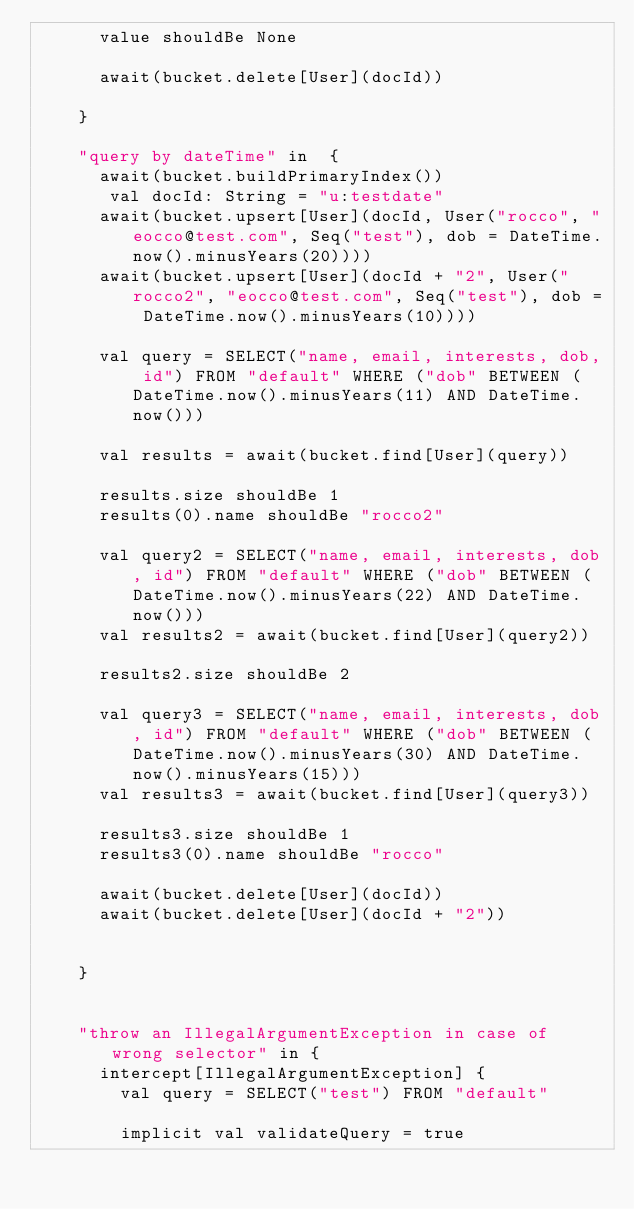Convert code to text. <code><loc_0><loc_0><loc_500><loc_500><_Scala_>      value shouldBe None

      await(bucket.delete[User](docId))

    }

    "query by dateTime" in  {
      await(bucket.buildPrimaryIndex())
       val docId: String = "u:testdate"
      await(bucket.upsert[User](docId, User("rocco", "eocco@test.com", Seq("test"), dob = DateTime.now().minusYears(20))))
      await(bucket.upsert[User](docId + "2", User("rocco2", "eocco@test.com", Seq("test"), dob = DateTime.now().minusYears(10))))

      val query = SELECT("name, email, interests, dob, id") FROM "default" WHERE ("dob" BETWEEN (DateTime.now().minusYears(11) AND DateTime.now()))

      val results = await(bucket.find[User](query))

      results.size shouldBe 1
      results(0).name shouldBe "rocco2"

      val query2 = SELECT("name, email, interests, dob, id") FROM "default" WHERE ("dob" BETWEEN (DateTime.now().minusYears(22) AND DateTime.now()))
      val results2 = await(bucket.find[User](query2))

      results2.size shouldBe 2

      val query3 = SELECT("name, email, interests, dob, id") FROM "default" WHERE ("dob" BETWEEN (DateTime.now().minusYears(30) AND DateTime.now().minusYears(15)))
      val results3 = await(bucket.find[User](query3))

      results3.size shouldBe 1
      results3(0).name shouldBe "rocco"

      await(bucket.delete[User](docId))
      await(bucket.delete[User](docId + "2"))


    }


    "throw an IllegalArgumentException in case of wrong selector" in {
      intercept[IllegalArgumentException] {
        val query = SELECT("test") FROM "default"

        implicit val validateQuery = true</code> 